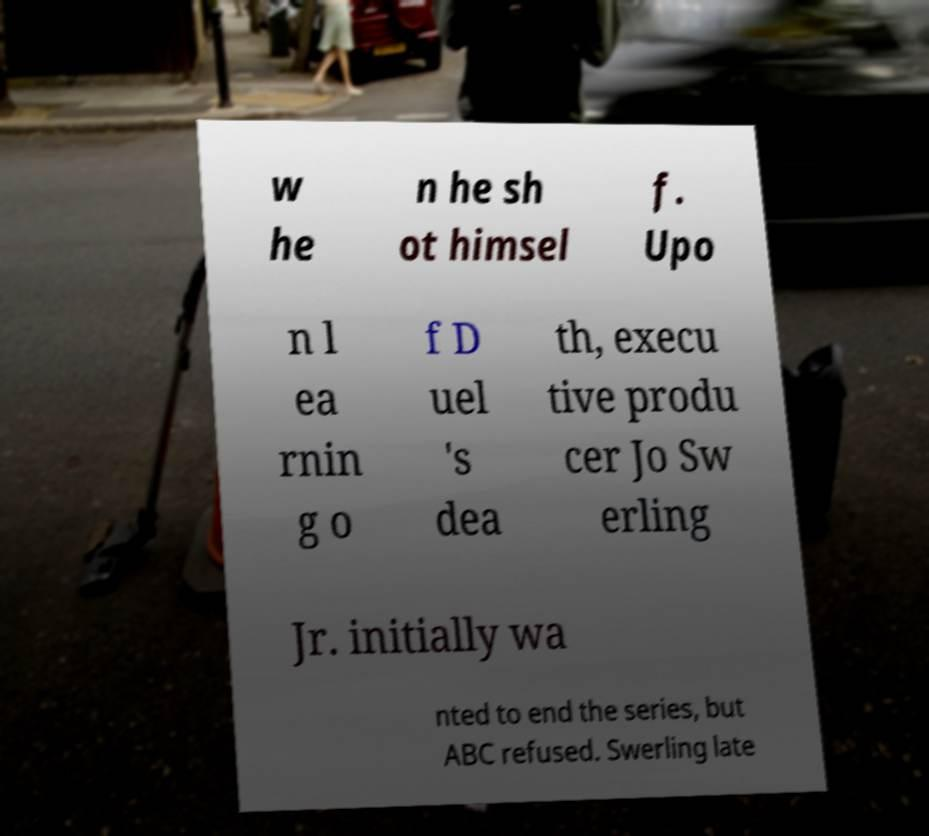Can you read and provide the text displayed in the image?This photo seems to have some interesting text. Can you extract and type it out for me? w he n he sh ot himsel f. Upo n l ea rnin g o f D uel 's dea th, execu tive produ cer Jo Sw erling Jr. initially wa nted to end the series, but ABC refused. Swerling late 